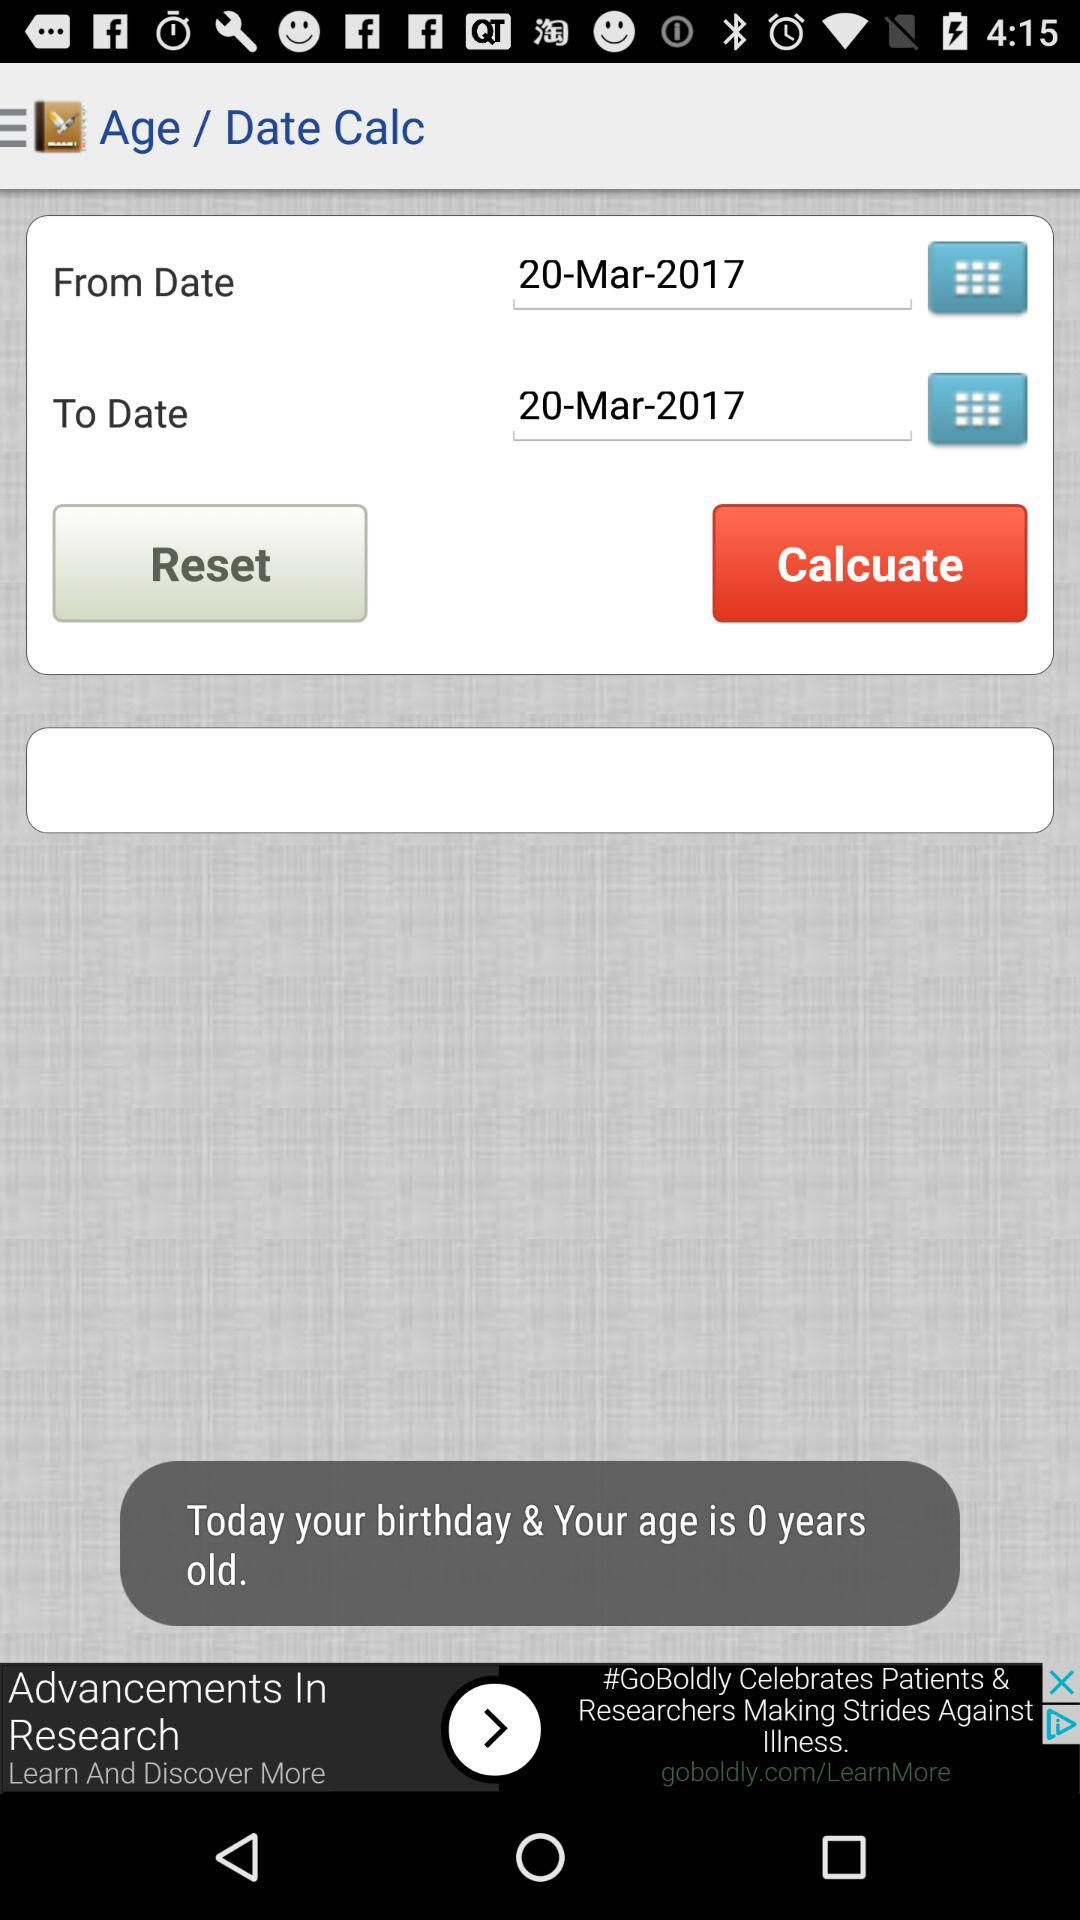What dates are used to calculate age? The dates are: 20-Mar-2017 and 20-Mar-2017. 